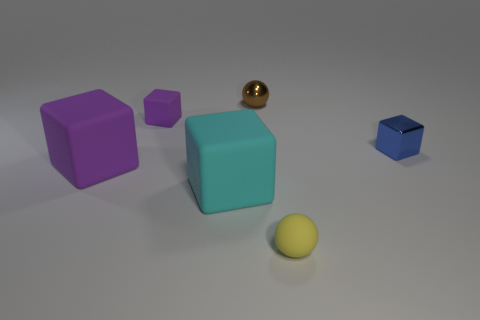What is the shape of the other big object that is made of the same material as the big cyan object?
Offer a terse response. Cube. Are there fewer metal cubes that are on the left side of the big purple rubber thing than brown metallic balls?
Make the answer very short. Yes. What color is the small cube that is on the left side of the tiny brown object?
Give a very brief answer. Purple. Is there a purple thing of the same shape as the tiny blue thing?
Give a very brief answer. Yes. What number of big cyan things have the same shape as the brown thing?
Keep it short and to the point. 0. Is the color of the tiny rubber ball the same as the tiny shiny ball?
Your answer should be compact. No. Is the number of small blue cubes less than the number of big matte cubes?
Provide a short and direct response. Yes. What is the material of the tiny block on the left side of the cyan rubber cube?
Your answer should be compact. Rubber. What material is the purple object that is the same size as the metallic ball?
Ensure brevity in your answer.  Rubber. The small ball behind the shiny thing on the right side of the tiny metal thing that is left of the tiny yellow rubber sphere is made of what material?
Give a very brief answer. Metal. 